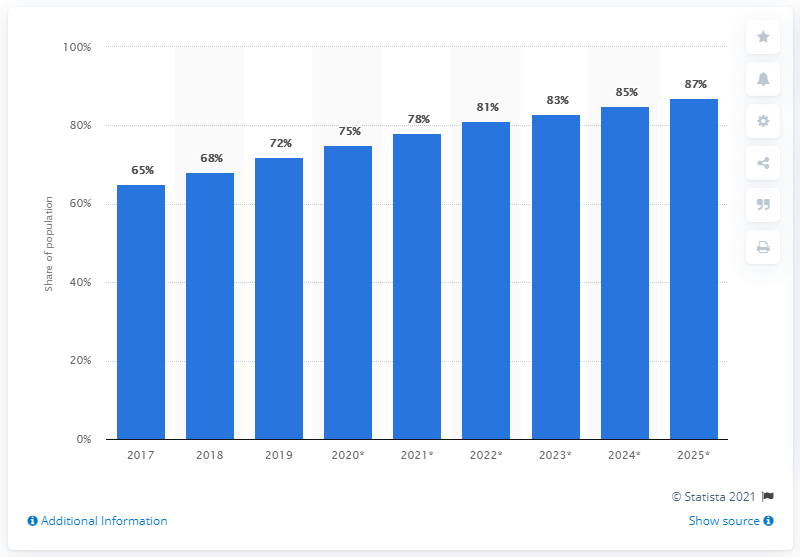Identify some key points in this picture. The projected growth of internet penetration in Thailand by 2025 is expected to reach 87%. 